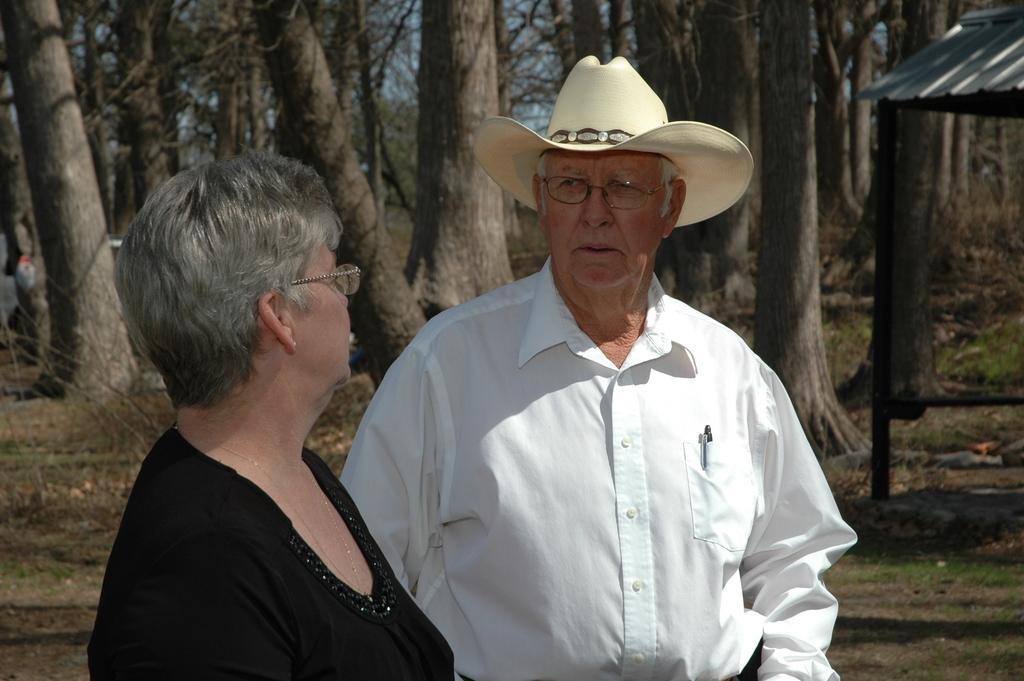Could you give a brief overview of what you see in this image? In this image we can see a man and a woman standing. In that a man is wearing a hat. On the backside we can see some grass, a shed, the bark of the trees, a group of trees and the sky. 